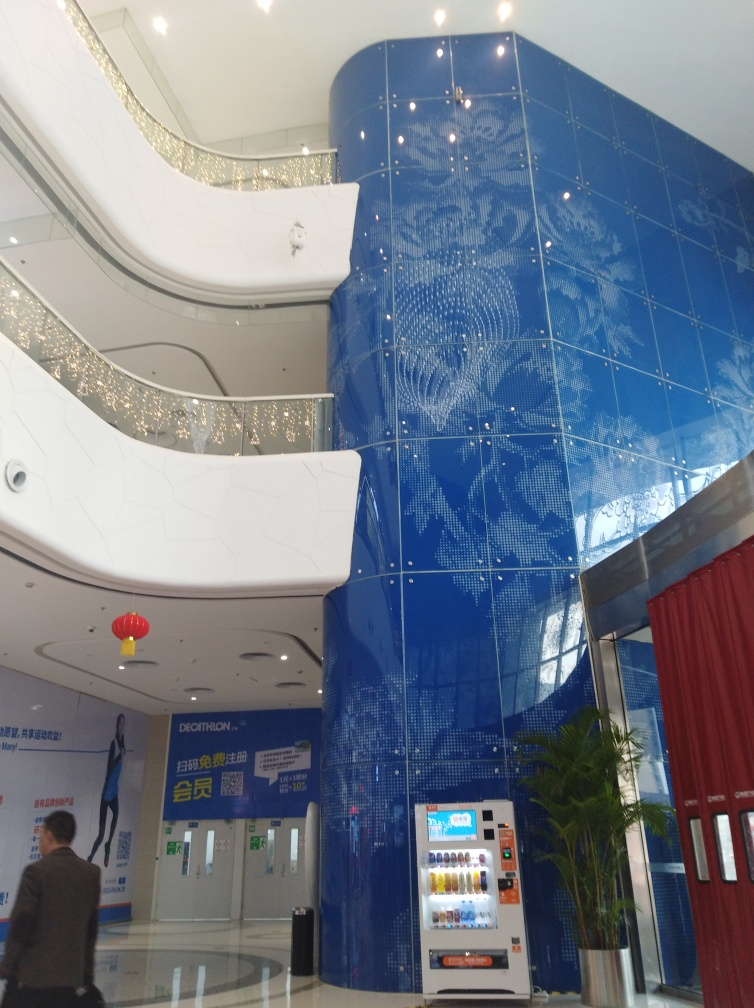Is the architectural style the main subject in the image? Yes, the architectural style is the focal point of the image, showcasing an interior space with a vibrant blue tile mosaic that creates a modern and sophisticated ambiance. The curvature of the walls and the placement of the lights appear to enhance the visual impact of the mosaic, drawing the viewer's attention to the patterns and the glossy finish of the tiles. 